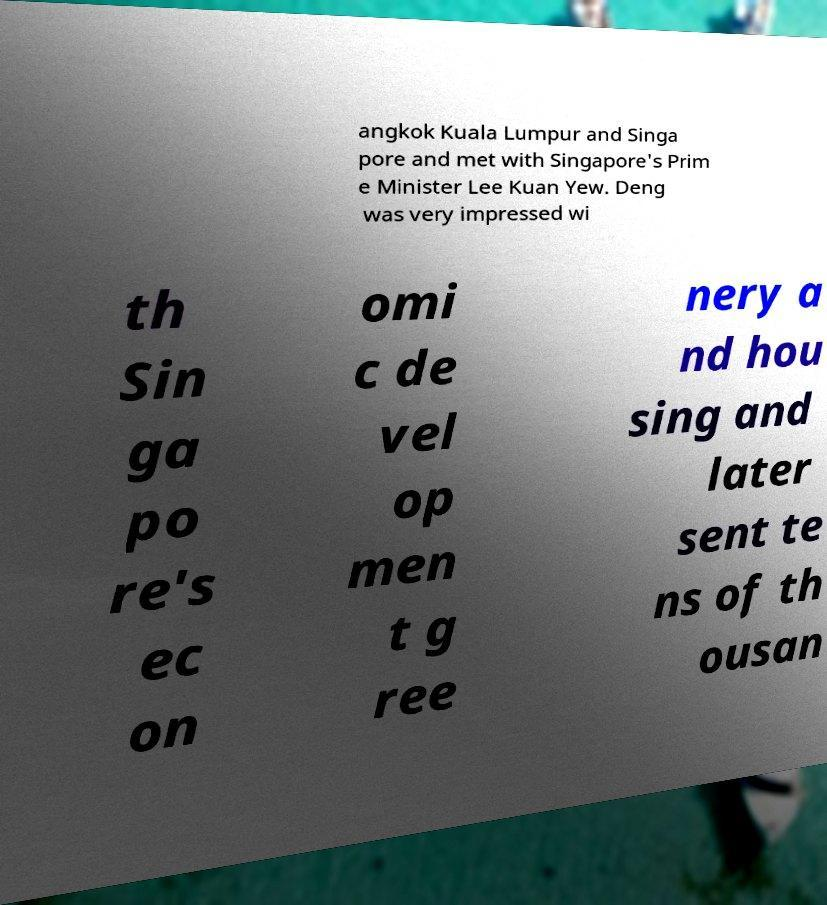Can you accurately transcribe the text from the provided image for me? angkok Kuala Lumpur and Singa pore and met with Singapore's Prim e Minister Lee Kuan Yew. Deng was very impressed wi th Sin ga po re's ec on omi c de vel op men t g ree nery a nd hou sing and later sent te ns of th ousan 